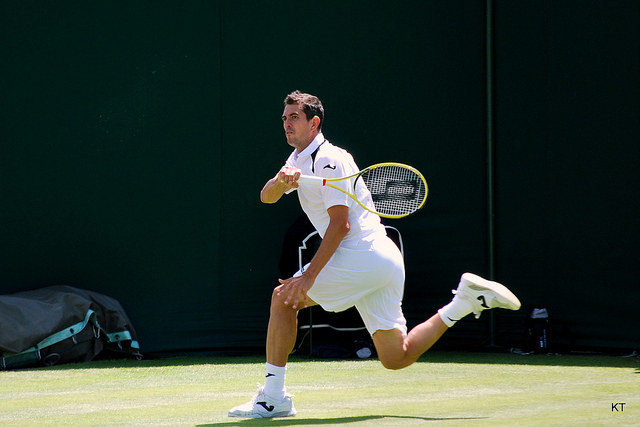Please transcribe the text in this image. KT 